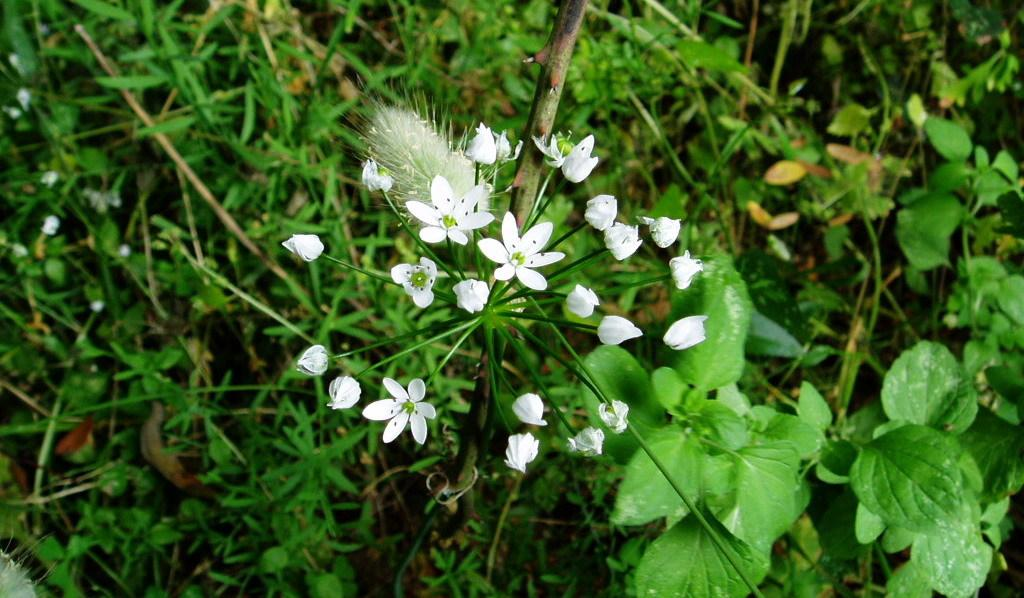What types of living organisms can be seen in the image? Plants and herbs are visible in the image. What specific features can be observed on the plants? The plants have flowers. What color are the flowers in the image? The flowers are white in color. Where might this image have been taken? The image might have been taken in a garden. How many gold bikes are visible in the image? There are no gold bikes present in the image; it features plants and herbs with white flowers. What type of heart-shaped object can be seen in the image? There is no heart-shaped object present in the image. 